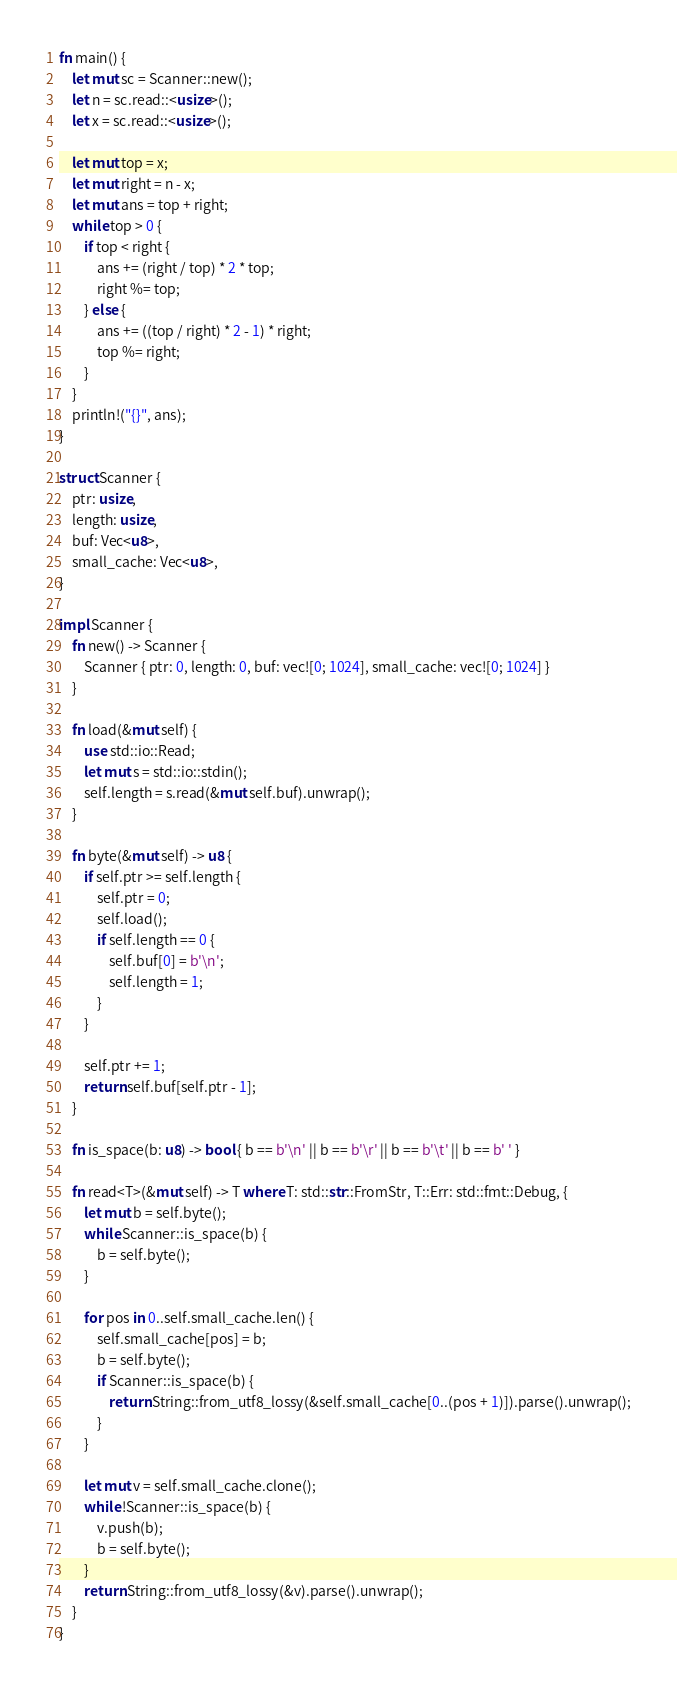Convert code to text. <code><loc_0><loc_0><loc_500><loc_500><_Rust_>fn main() {
    let mut sc = Scanner::new();
    let n = sc.read::<usize>();
    let x = sc.read::<usize>();

    let mut top = x;
    let mut right = n - x;
    let mut ans = top + right;
    while top > 0 {
        if top < right {
            ans += (right / top) * 2 * top;
            right %= top;
        } else {
            ans += ((top / right) * 2 - 1) * right;
            top %= right;
        }
    }
    println!("{}", ans);
}

struct Scanner {
    ptr: usize,
    length: usize,
    buf: Vec<u8>,
    small_cache: Vec<u8>,
}

impl Scanner {
    fn new() -> Scanner {
        Scanner { ptr: 0, length: 0, buf: vec![0; 1024], small_cache: vec![0; 1024] }
    }

    fn load(&mut self) {
        use std::io::Read;
        let mut s = std::io::stdin();
        self.length = s.read(&mut self.buf).unwrap();
    }

    fn byte(&mut self) -> u8 {
        if self.ptr >= self.length {
            self.ptr = 0;
            self.load();
            if self.length == 0 {
                self.buf[0] = b'\n';
                self.length = 1;
            }
        }

        self.ptr += 1;
        return self.buf[self.ptr - 1];
    }

    fn is_space(b: u8) -> bool { b == b'\n' || b == b'\r' || b == b'\t' || b == b' ' }

    fn read<T>(&mut self) -> T where T: std::str::FromStr, T::Err: std::fmt::Debug, {
        let mut b = self.byte();
        while Scanner::is_space(b) {
            b = self.byte();
        }

        for pos in 0..self.small_cache.len() {
            self.small_cache[pos] = b;
            b = self.byte();
            if Scanner::is_space(b) {
                return String::from_utf8_lossy(&self.small_cache[0..(pos + 1)]).parse().unwrap();
            }
        }

        let mut v = self.small_cache.clone();
        while !Scanner::is_space(b) {
            v.push(b);
            b = self.byte();
        }
        return String::from_utf8_lossy(&v).parse().unwrap();
    }
}

</code> 